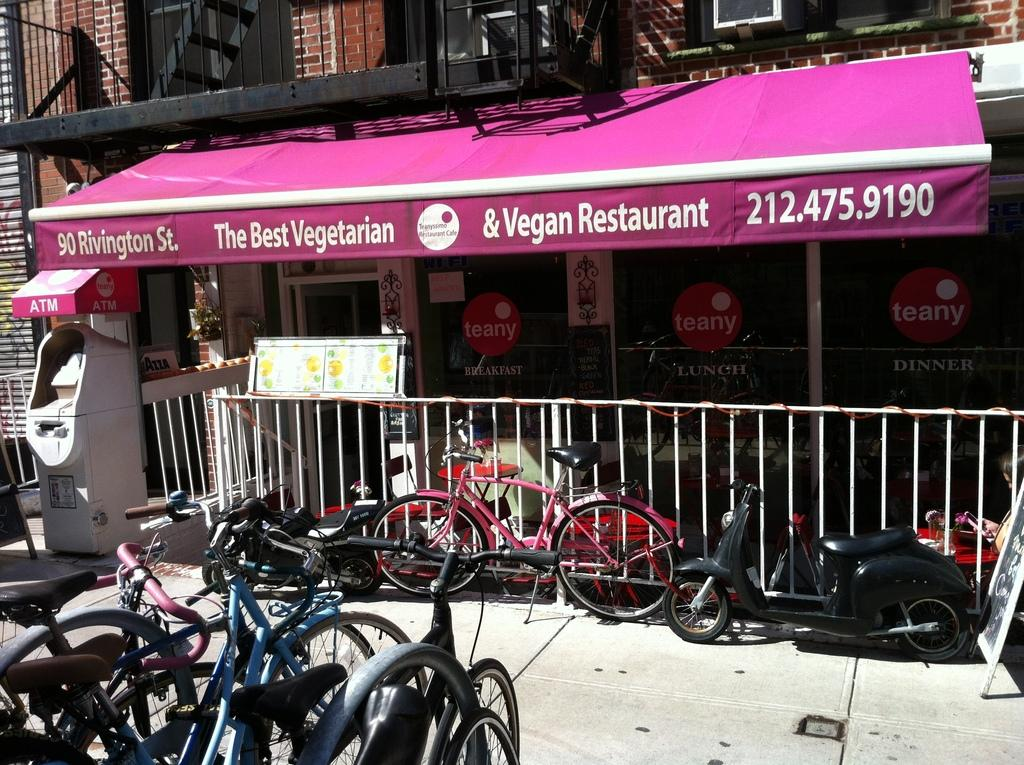What types of transportation can be seen in the image? There are vehicles in the image. What safety feature is visible in the image? Railings are visible in the image. What kind of equipment is present in the image? A machine is present in the image. What type of surface is in the image? Boards are in the image. What type of structure is in the image? There is a building in the image. What type of advertisement is visible in the image? Posters on glass are visible in the image. What type of business is present in the image? A store is present in the image. What general category of items can be seen in the image? There are objects in the image. What type of cork can be seen in the image? There is no cork present in the image. What type of chess pieces can be seen in the image? There are no chess pieces present in the image. 